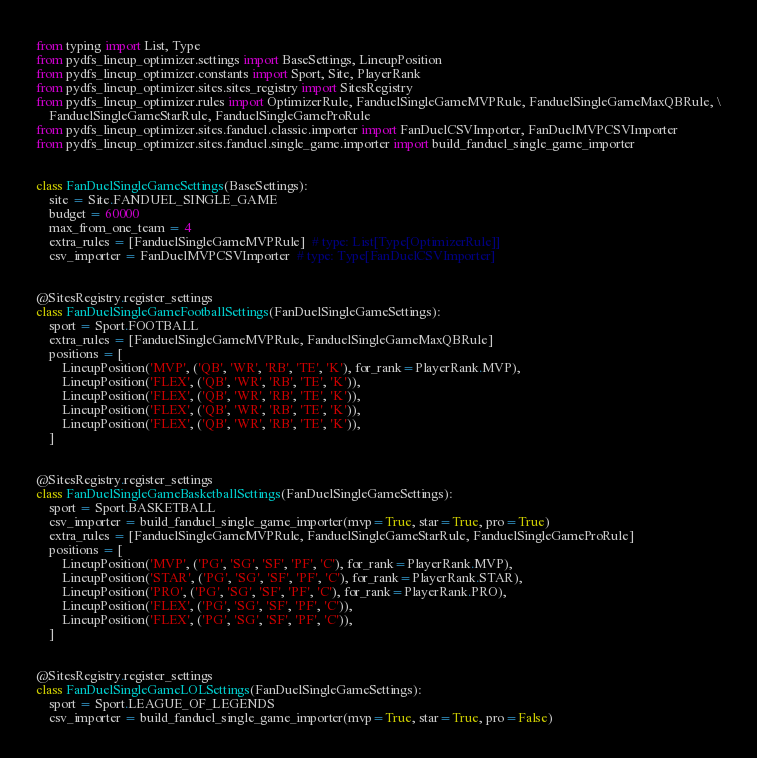Convert code to text. <code><loc_0><loc_0><loc_500><loc_500><_Python_>from typing import List, Type
from pydfs_lineup_optimizer.settings import BaseSettings, LineupPosition
from pydfs_lineup_optimizer.constants import Sport, Site, PlayerRank
from pydfs_lineup_optimizer.sites.sites_registry import SitesRegistry
from pydfs_lineup_optimizer.rules import OptimizerRule, FanduelSingleGameMVPRule, FanduelSingleGameMaxQBRule, \
    FanduelSingleGameStarRule, FanduelSingleGameProRule
from pydfs_lineup_optimizer.sites.fanduel.classic.importer import FanDuelCSVImporter, FanDuelMVPCSVImporter
from pydfs_lineup_optimizer.sites.fanduel.single_game.importer import build_fanduel_single_game_importer


class FanDuelSingleGameSettings(BaseSettings):
    site = Site.FANDUEL_SINGLE_GAME
    budget = 60000
    max_from_one_team = 4
    extra_rules = [FanduelSingleGameMVPRule]  # type: List[Type[OptimizerRule]]
    csv_importer = FanDuelMVPCSVImporter  # type: Type[FanDuelCSVImporter]


@SitesRegistry.register_settings
class FanDuelSingleGameFootballSettings(FanDuelSingleGameSettings):
    sport = Sport.FOOTBALL
    extra_rules = [FanduelSingleGameMVPRule, FanduelSingleGameMaxQBRule]
    positions = [
        LineupPosition('MVP', ('QB', 'WR', 'RB', 'TE', 'K'), for_rank=PlayerRank.MVP),
        LineupPosition('FLEX', ('QB', 'WR', 'RB', 'TE', 'K')),
        LineupPosition('FLEX', ('QB', 'WR', 'RB', 'TE', 'K')),
        LineupPosition('FLEX', ('QB', 'WR', 'RB', 'TE', 'K')),
        LineupPosition('FLEX', ('QB', 'WR', 'RB', 'TE', 'K')),
    ]


@SitesRegistry.register_settings
class FanDuelSingleGameBasketballSettings(FanDuelSingleGameSettings):
    sport = Sport.BASKETBALL
    csv_importer = build_fanduel_single_game_importer(mvp=True, star=True, pro=True)
    extra_rules = [FanduelSingleGameMVPRule, FanduelSingleGameStarRule, FanduelSingleGameProRule]
    positions = [
        LineupPosition('MVP', ('PG', 'SG', 'SF', 'PF', 'C'), for_rank=PlayerRank.MVP),
        LineupPosition('STAR', ('PG', 'SG', 'SF', 'PF', 'C'), for_rank=PlayerRank.STAR),
        LineupPosition('PRO', ('PG', 'SG', 'SF', 'PF', 'C'), for_rank=PlayerRank.PRO),
        LineupPosition('FLEX', ('PG', 'SG', 'SF', 'PF', 'C')),
        LineupPosition('FLEX', ('PG', 'SG', 'SF', 'PF', 'C')),
    ]


@SitesRegistry.register_settings
class FanDuelSingleGameLOLSettings(FanDuelSingleGameSettings):
    sport = Sport.LEAGUE_OF_LEGENDS
    csv_importer = build_fanduel_single_game_importer(mvp=True, star=True, pro=False)</code> 